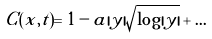<formula> <loc_0><loc_0><loc_500><loc_500>C ( x , t ) = 1 - a | y | { \sqrt { \log | y | } } + \dots</formula> 